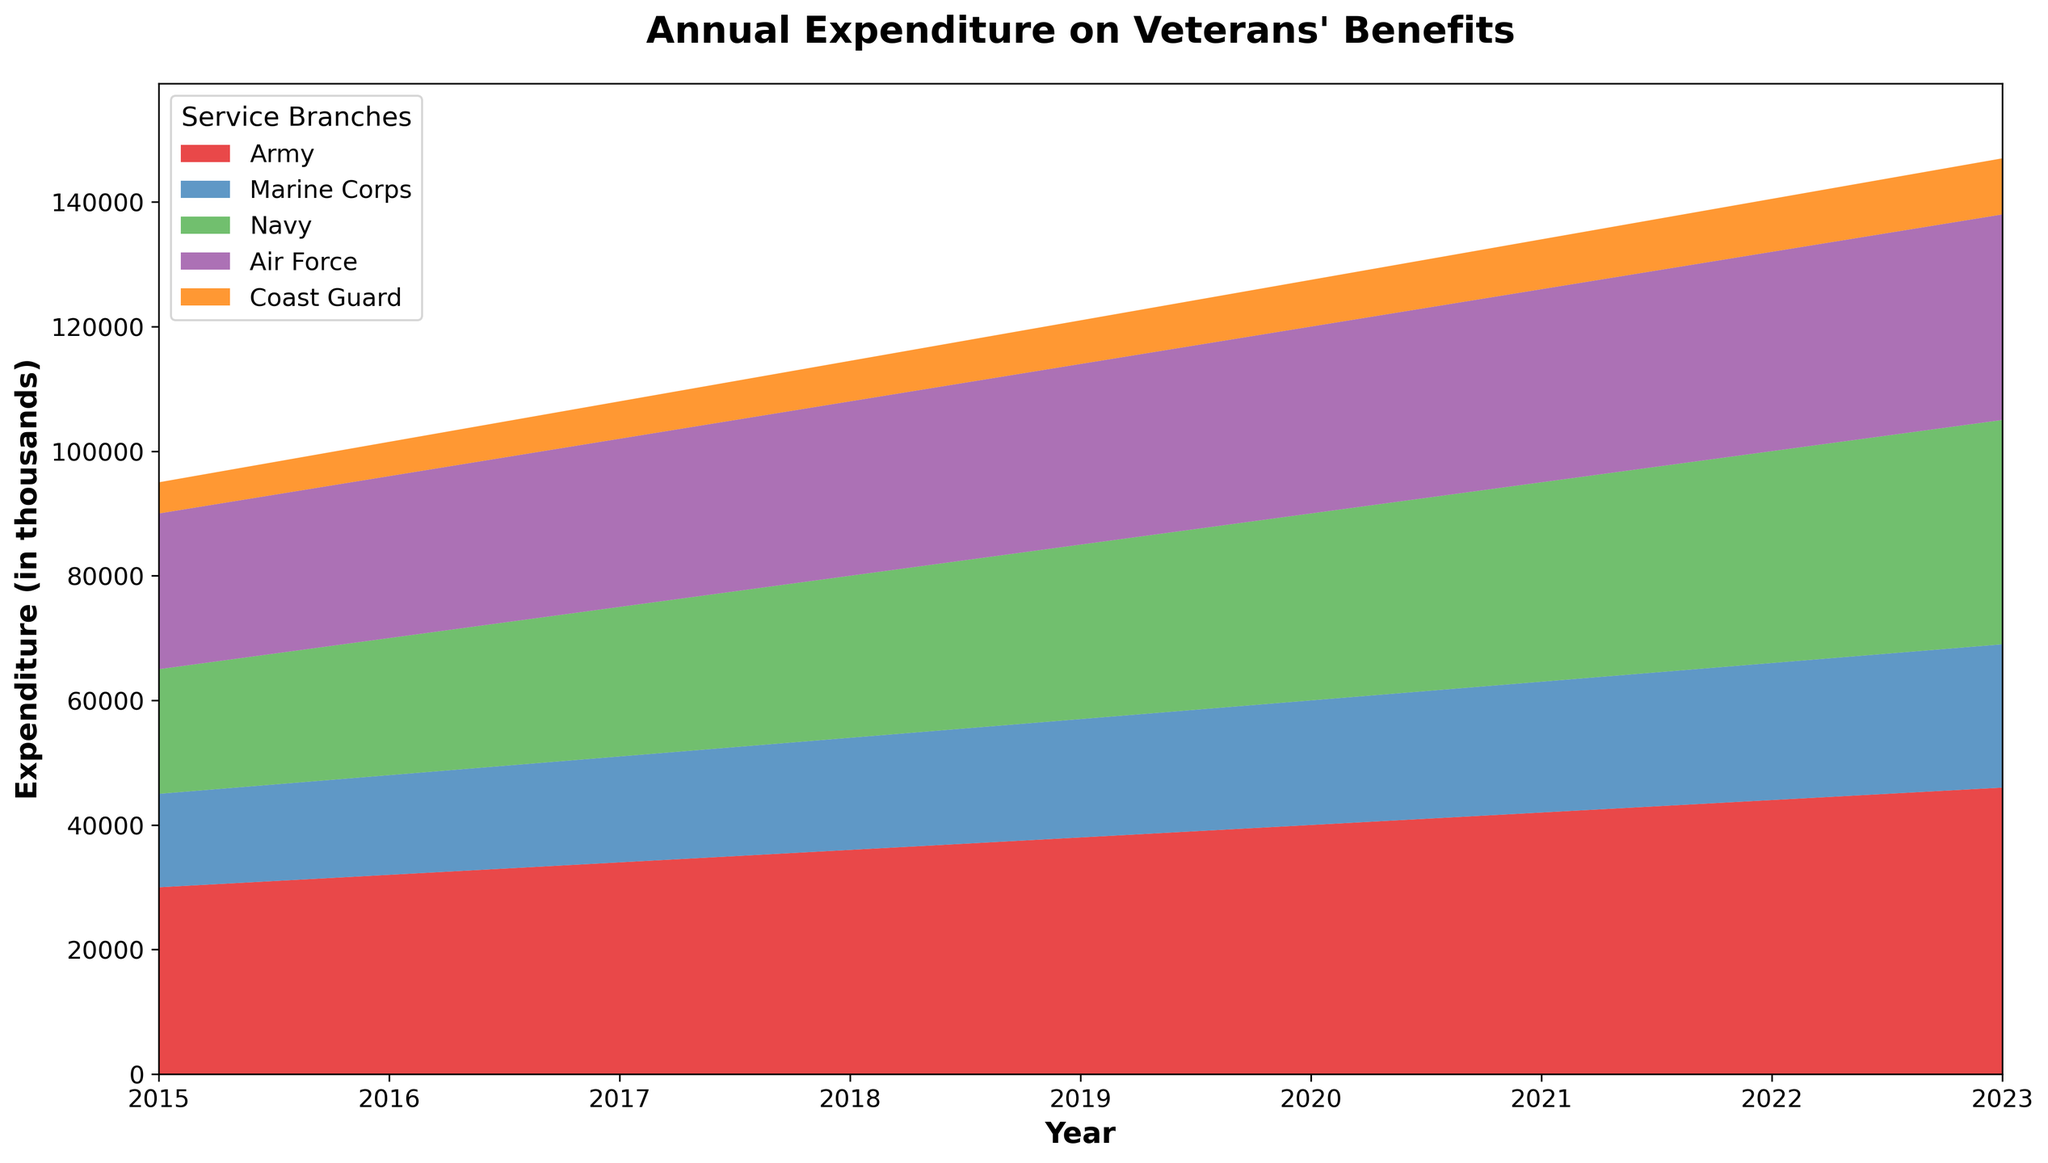What is the trend of the Army's expenditure from 2015 to 2023? The Army's expenditure shows a steady increasing trend annually. Start from the value in 2015 (30000) and observe the gradual increase every year until 2023 (46000).
Answer: Increasing trend Which service branch saw the largest increase in expenditure from 2015 to 2023? Compute the difference between the 2023 and 2015 expenditure for each branch. Army: 16000, Marine Corps: 8000, Navy: 16000, Air Force: 8000, Coast Guard: 4000. The Army and the Navy saw the largest increase of 16000.
Answer: Army and Navy Is the expenditure on the Coast Guard consistently increasing each year? Check the Coast Guard expenditure values for each year from 2015 to 2023 and confirm if each subsequent year’s value is larger than the previous year, which they are (5000 to 9000).
Answer: Yes Which branches had an expenditure of more than 30000 in 2023? Refer to the data for 2023 and list the branches with values greater than 30000: Army (46000), Marine Corps (23000), Navy (36000), Air Force (33000), Coast Guard (9000). So it is Army, Navy, and Air Force.
Answer: Army, Navy, Air Force What is the total expenditure on Veterans' benefits in 2020? Sum the expenditures of all branches in 2020: 40000 (Army) + 20000 (Marine Corps) + 30000 (Navy) + 30000 (Air Force) + 7500 (Coast Guard) = 127500.
Answer: 127500 By how much did the Navy's expenditure change from 2015 to 2018? Subtract Navy's 2015 value (20000) from its 2018 value (26000): 26000 - 20000 = 6000.
Answer: 6000 In 2021, which two service branches had the closest expenditures? Compare the 2021 expenditures of all branches and identify the two closest pairs. Navy (32000) and Air Force (31000) have the smallest difference of 1000.
Answer: Navy and Air Force What is the average annual expenditure of the Marine Corps over the given period? Sum the Marine Corps expenditures from 2015 to 2023 and divide by the number of years. Sum: 15000 + 16000 + 17000 + 18000 + 19000 + 20000 + 21000 + 22000 + 23000 = 171000. Average: 171000/9 = 19000.
Answer: 19000 How does the Air Force's expenditure in 2019 compare with its expenditure in 2016? Compare the values directly: 29000 (2019) - 26000 (2016) = 3000. The Air Force's expenditure increased by 3000.
Answer: Increased by 3000 